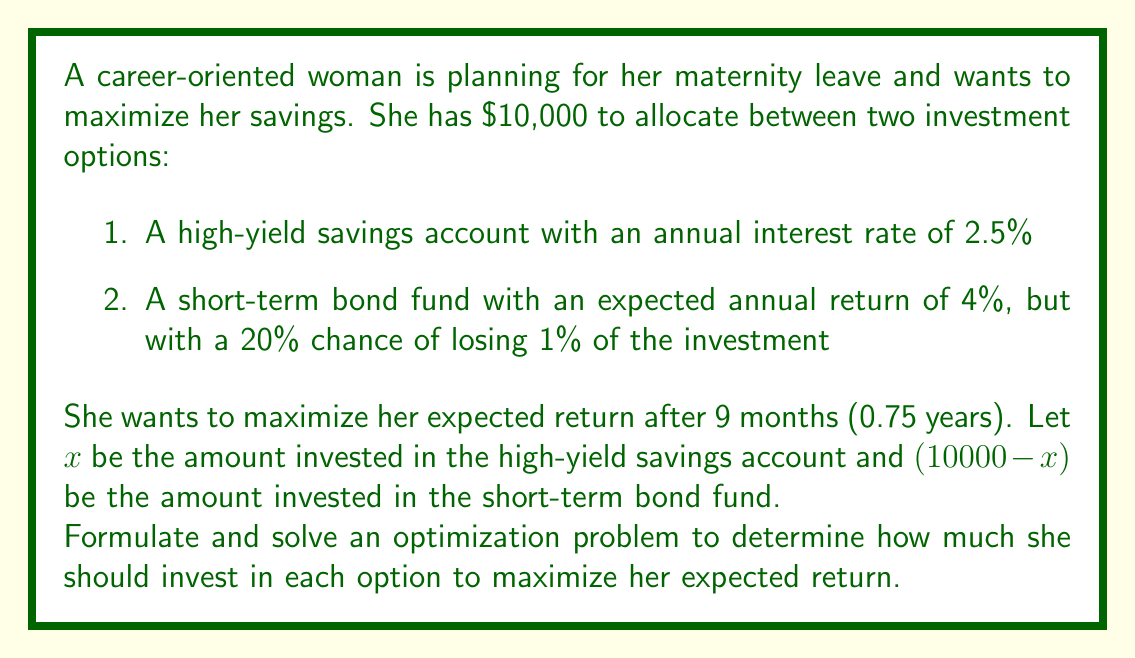Can you answer this question? To solve this optimization problem, we need to:
1. Formulate the objective function
2. Identify any constraints
3. Find the maximum of the function

Step 1: Formulate the objective function

Let's define our objective function $f(x)$ as the expected return after 9 months:

$f(x) = x(1 + 0.025 \cdot 0.75) + (10000-x)(0.8 \cdot (1 + 0.04 \cdot 0.75) + 0.2 \cdot (1 - 0.01 \cdot 0.75))$

Simplifying:
$f(x) = 1.01875x + (10000-x)(0.8 \cdot 1.03 + 0.2 \cdot 0.9925)$
$f(x) = 1.01875x + (10000-x)(0.824 + 0.1985)$
$f(x) = 1.01875x + 10225 - 1.0225x$
$f(x) = 10225 - 0.00375x$

Step 2: Identify constraints

The constraints are:
$0 \leq x \leq 10000$

Step 3: Find the maximum

Since $f(x)$ is a linear function, its maximum will occur at one of the extreme points of the constraint interval.

At $x = 0$: $f(0) = 10225$
At $x = 10000$: $f(10000) = 10225 - 37.5 = 10187.5$

Therefore, the maximum occurs at $x = 0$.
Answer: To maximize her expected return, the woman should invest all $10,000 in the short-term bond fund, resulting in an expected return of $10,225 after 9 months. 